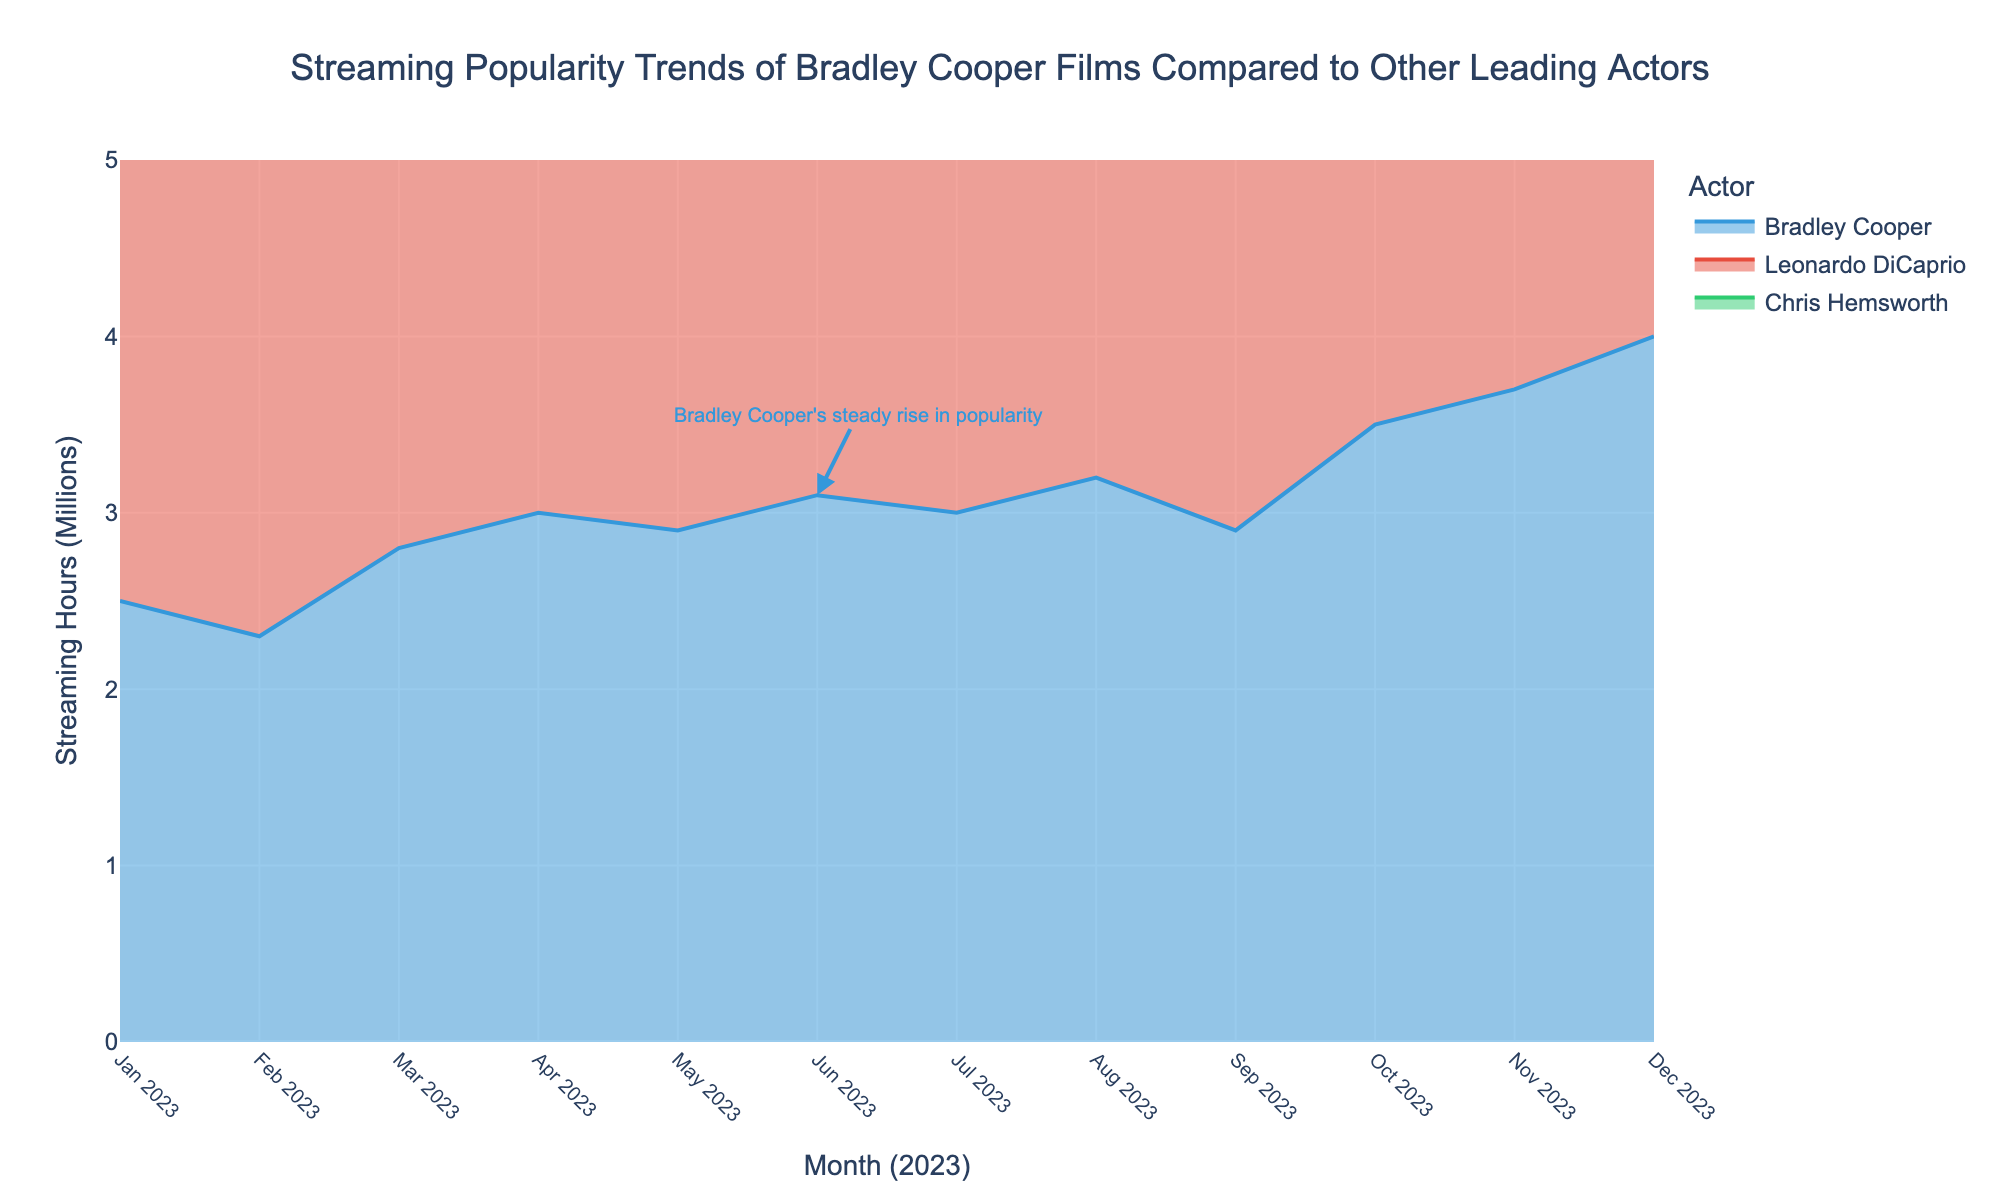Which actor had the highest streaming hours in December 2023? By looking at the peak of the streaming hours in December 2023, Leonardo DiCaprio had the highest streaming hours with 4.5 million.
Answer: Leonardo DiCaprio How many months did Bradley Cooper's streaming hours increase consecutively from January to June 2023? Bradley Cooper's streaming hours increased from January (2.5M) to February (2.3M) but then decreased. However, they increased again from February (2.3M) to June (3.1M). Thus, he had an increasing trend for 5 months from February to June 2023.
Answer: 5 months Which actor experienced the largest month-over-month increase in October 2023? Comparing the changes from September to October among all actors, Bradley Cooper saw an increase from 2.9M to 3.5M (0.6M increase), Leonardo DiCaprio from 3.8M to 4.1M (0.3M increase), and Chris Hemsworth from 2.4M to 2.8M (0.4M increase). Bradley Cooper had the largest increase of 0.6M.
Answer: Bradley Cooper What is the difference in streaming hours between Bradley Cooper and Leonardo DiCaprio in November 2023? In November 2023, Bradley Cooper had 3.7 million streaming hours while Leonardo DiCaprio had 4.3 million. The difference is 4.3M - 3.7M = 0.6M.
Answer: 0.6 million What is the overall trend in Bradley Cooper's streaming hours throughout 2023? Observing the graph, Bradley Cooper's streaming hours show a general upward trend, with some fluctuations. It starts at 2.5M in January and ends at 4.0M in December, indicating an overall increase over the year.
Answer: Upward trend 